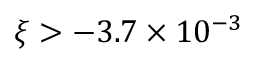Convert formula to latex. <formula><loc_0><loc_0><loc_500><loc_500>\xi > - 3 . 7 \times 1 0 ^ { - 3 }</formula> 